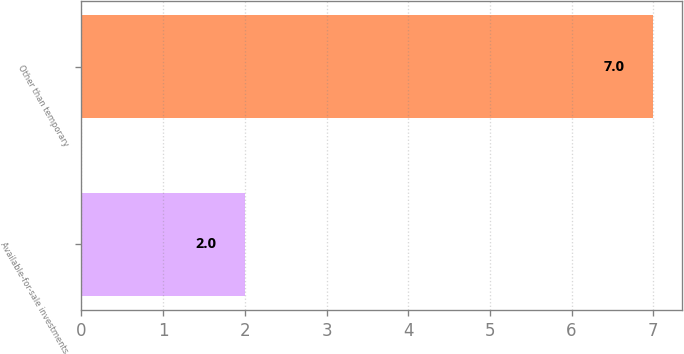Convert chart. <chart><loc_0><loc_0><loc_500><loc_500><bar_chart><fcel>Available-for-sale investments<fcel>Other than temporary<nl><fcel>2<fcel>7<nl></chart> 